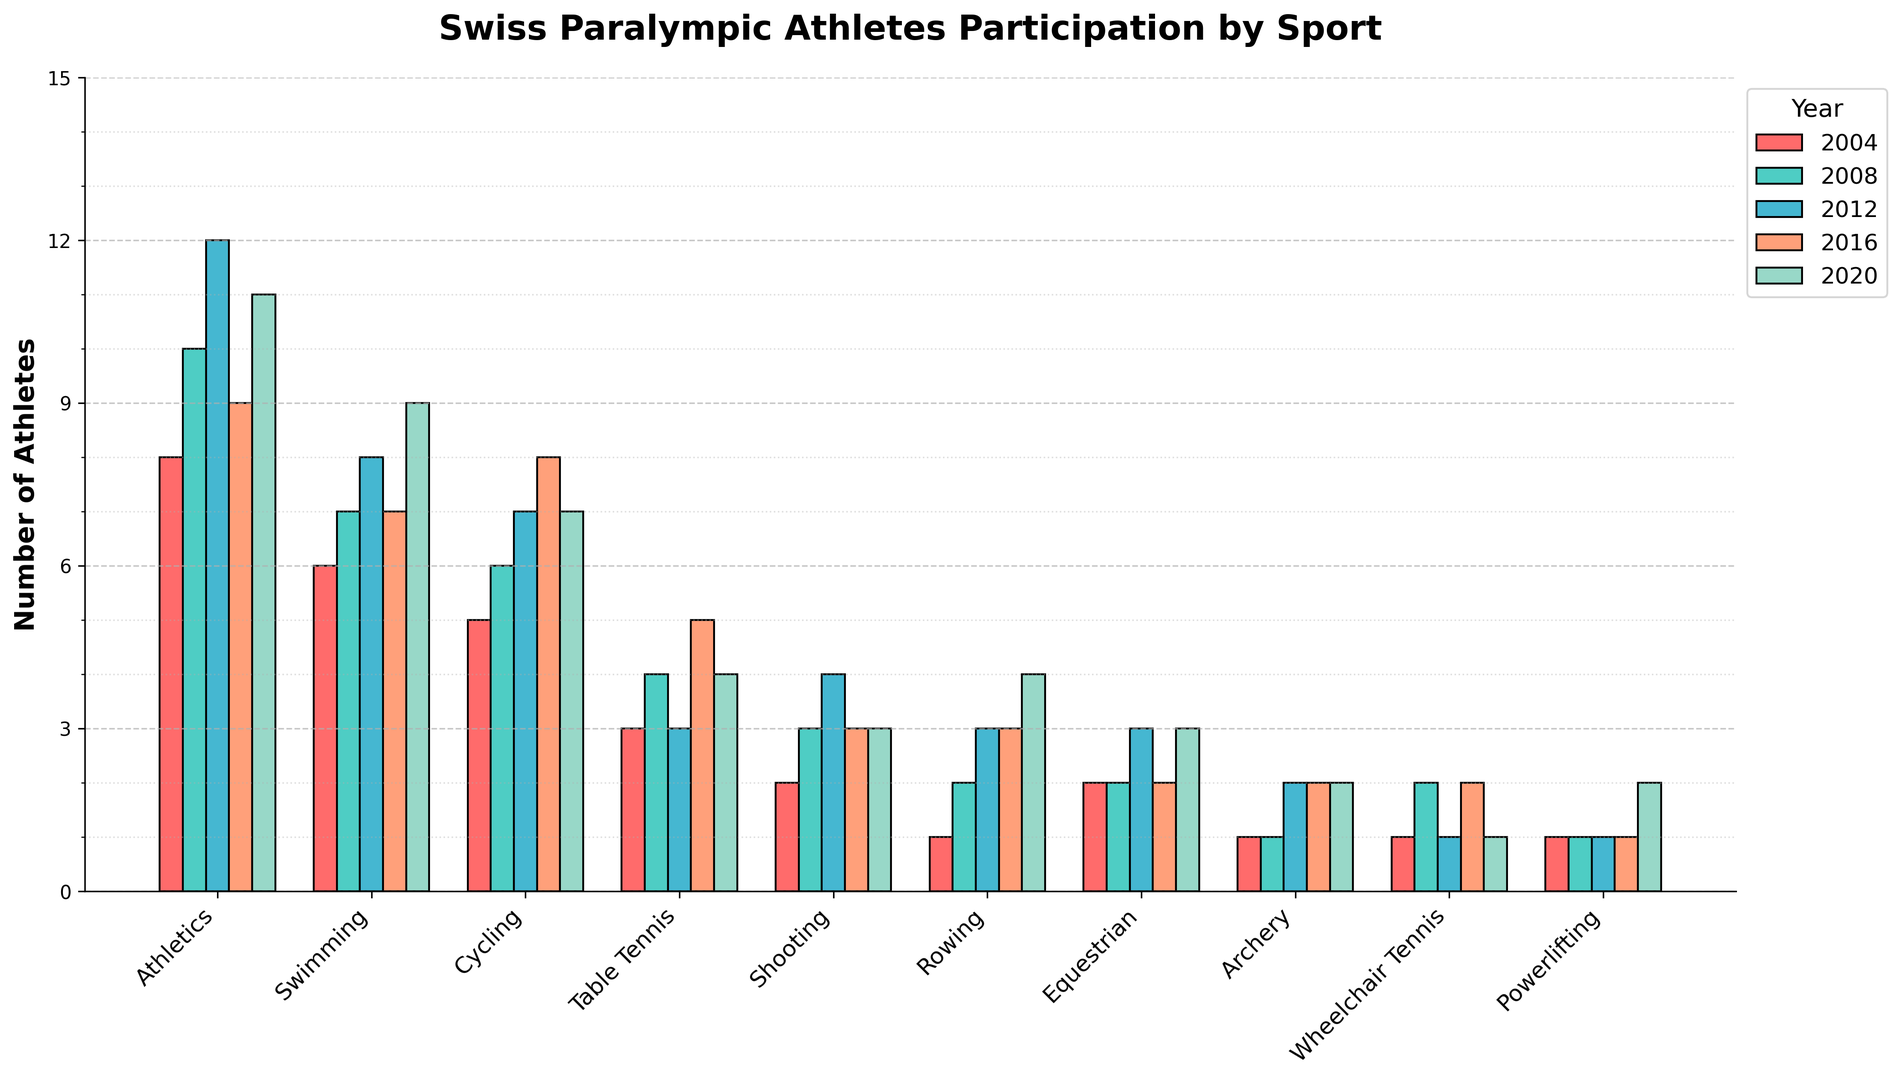How many athletes participated in athletics in the 2020 Paralympics? Look at the bar associated with Athletics for the year 2020 to see its height, which represents the number of athletes.
Answer: 11 Which sport had the highest participation in 2012? Identify which bar is tallest in the year 2012 among all sports.
Answer: Athletics How did the number of athletes in swimming change from 2008 to 2020? Compare the heights of the bars for Swimming in 2008 and 2020 to see the difference in participation.
Answer: Increased by 2 Which sport had the least number of participants in 2004? Look for the shortest bar in the 2004 group to determine the sport with the fewest athletes.
Answer: Archery What is the average number of athletes participating in Rowing over the five Paralympics? Add the participation numbers for Rowing from 2004 to 2020 and then divide by 5. Calculation: (1 + 2 + 3 + 3 + 4) / 5 = 2.6
Answer: 2.6 Were there any sports that had a decrease in participation from 2016 to 2020? Compare the heights of the bars from 2016 and 2020 for each sport to see if any sport has a shorter bar in 2020.
Answer: Yes, Cycling and Wheelchair Tennis Which year saw an increase in participants for Shooting compared to the previous Paralympics? Compare the bars year by year for Shooting and note any year where the height increased.
Answer: 2008 and 2012 How many more athletes participated in Table Tennis in 2016 compared to 2004? Subtract the number of Table Tennis athletes in 2004 from the number in 2016. Calculation: 5 - 3 = 2
Answer: 2 Did Powerlifting participation increase, decrease, or stay the same from 2004 to 2020? Compare the heights of the Powerlifting bars for 2004 and 2020.
Answer: Increase What is the total number of participants in Equestrian from 2004 to 2020? Add the participation numbers for Equestrian for all years. Calculation: 2 + 2 + 3 + 2 + 3 = 12
Answer: 12 